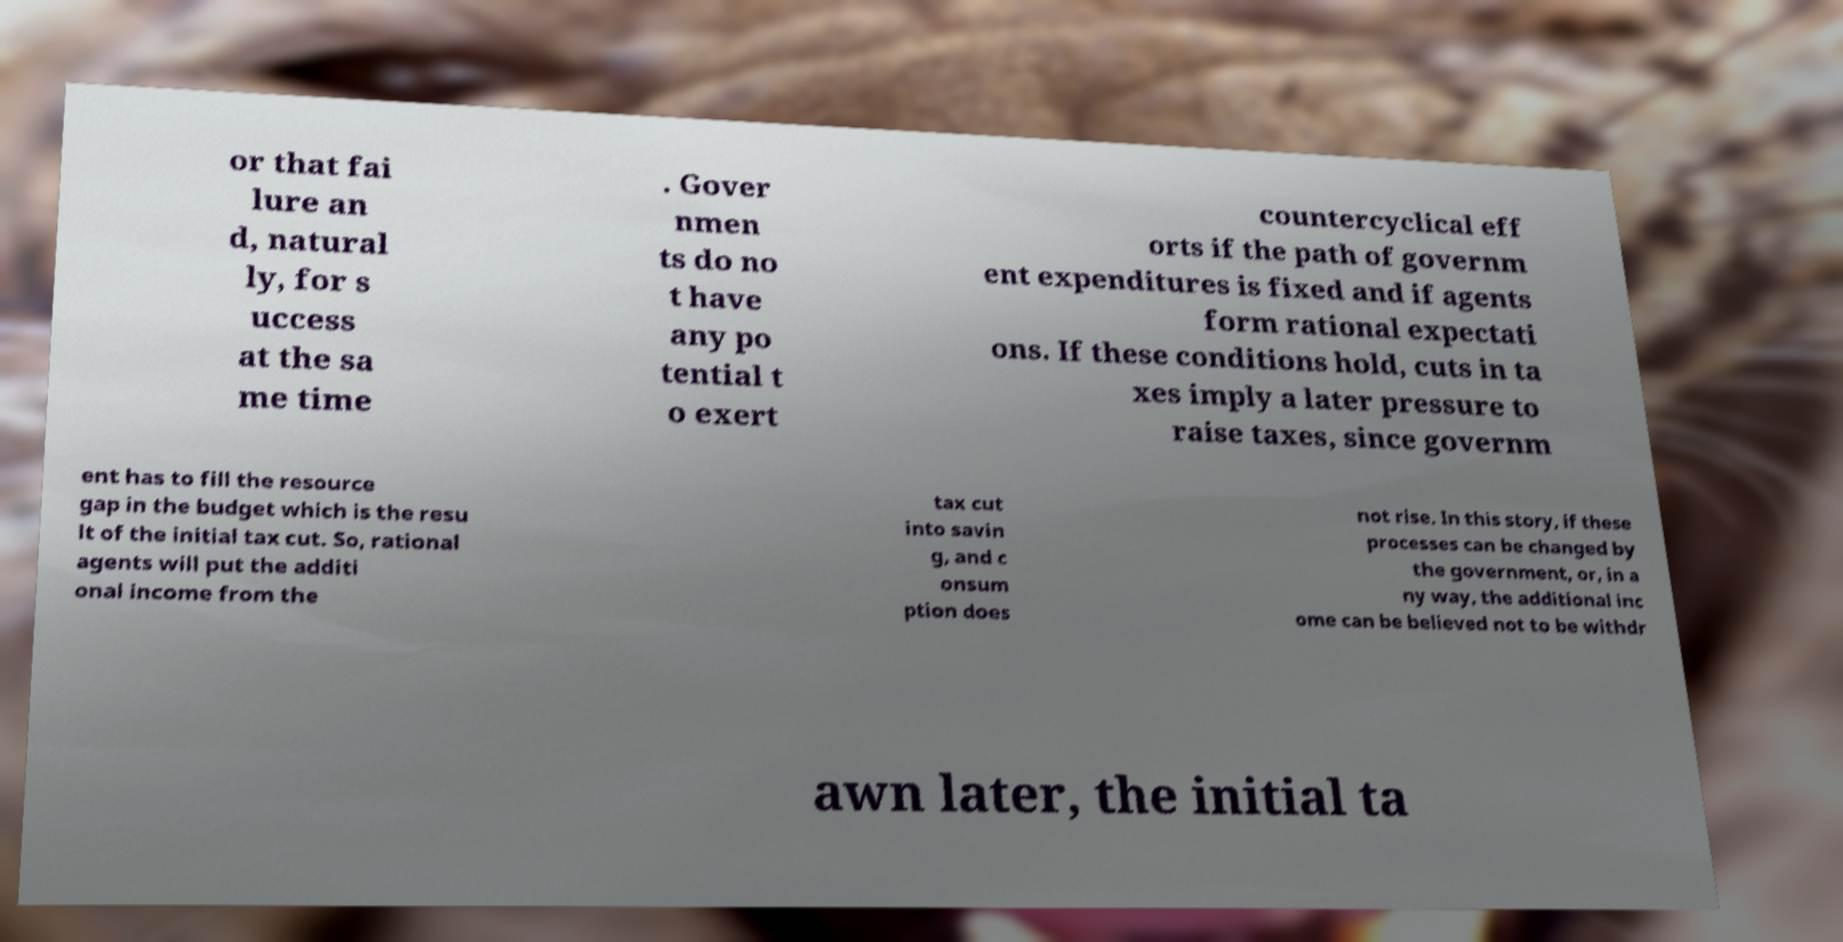Can you accurately transcribe the text from the provided image for me? or that fai lure an d, natural ly, for s uccess at the sa me time . Gover nmen ts do no t have any po tential t o exert countercyclical eff orts if the path of governm ent expenditures is fixed and if agents form rational expectati ons. If these conditions hold, cuts in ta xes imply a later pressure to raise taxes, since governm ent has to fill the resource gap in the budget which is the resu lt of the initial tax cut. So, rational agents will put the additi onal income from the tax cut into savin g, and c onsum ption does not rise. In this story, if these processes can be changed by the government, or, in a ny way, the additional inc ome can be believed not to be withdr awn later, the initial ta 